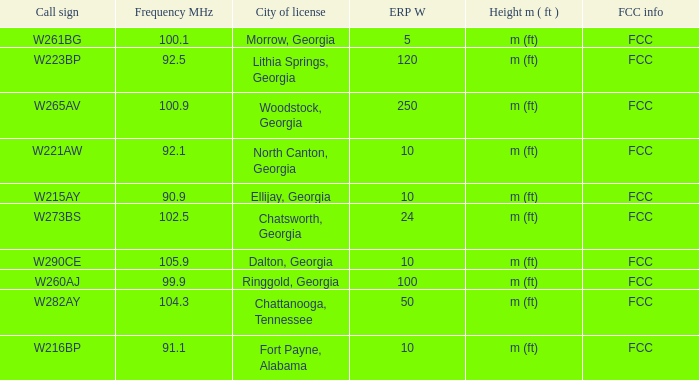What is the number of Frequency MHz in woodstock, georgia? 100.9. 